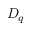Convert formula to latex. <formula><loc_0><loc_0><loc_500><loc_500>D _ { q }</formula> 